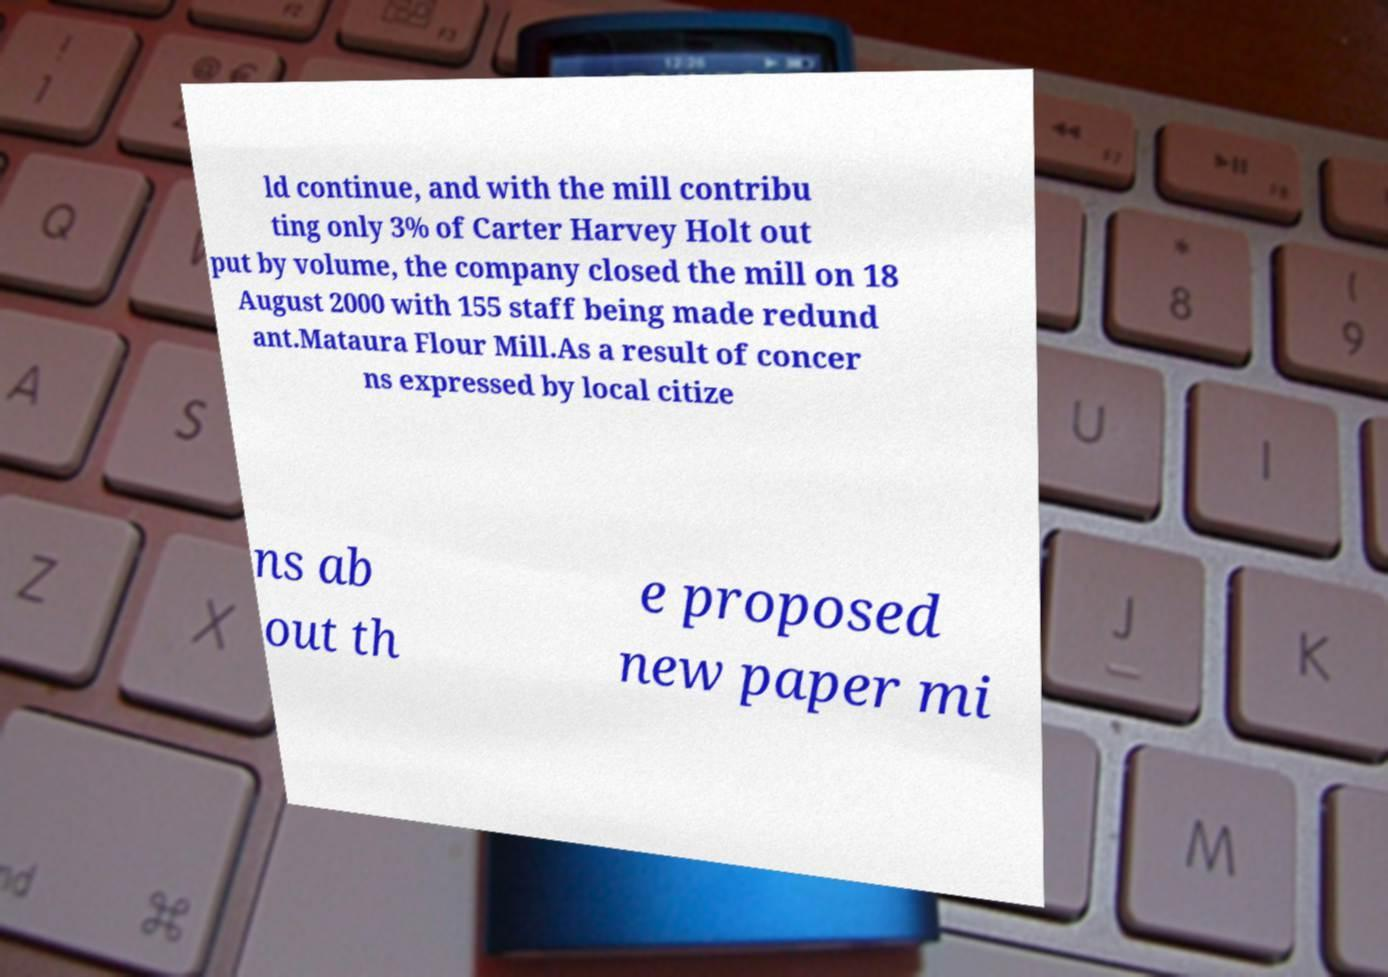Please read and relay the text visible in this image. What does it say? ld continue, and with the mill contribu ting only 3% of Carter Harvey Holt out put by volume, the company closed the mill on 18 August 2000 with 155 staff being made redund ant.Mataura Flour Mill.As a result of concer ns expressed by local citize ns ab out th e proposed new paper mi 